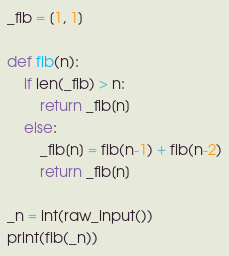<code> <loc_0><loc_0><loc_500><loc_500><_Python_>_fib = [1, 1]

def fib(n):
    if len(_fib) > n:
        return _fib[n]
    else:
        _fib[n] = fib(n-1) + fib(n-2)
        return _fib[n]

_n = int(raw_input())
print(fib(_n))</code> 